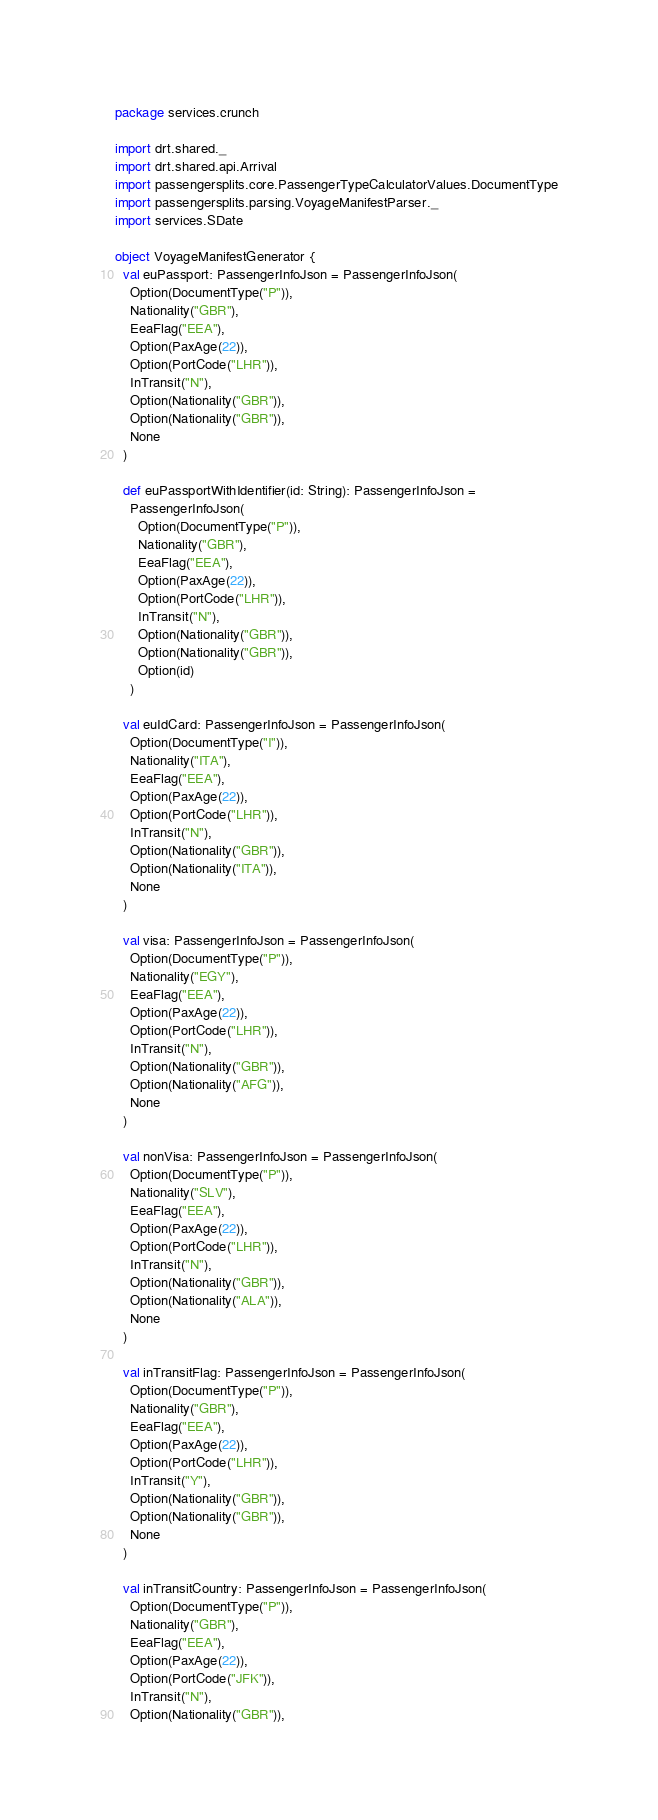<code> <loc_0><loc_0><loc_500><loc_500><_Scala_>package services.crunch

import drt.shared._
import drt.shared.api.Arrival
import passengersplits.core.PassengerTypeCalculatorValues.DocumentType
import passengersplits.parsing.VoyageManifestParser._
import services.SDate

object VoyageManifestGenerator {
  val euPassport: PassengerInfoJson = PassengerInfoJson(
    Option(DocumentType("P")),
    Nationality("GBR"),
    EeaFlag("EEA"),
    Option(PaxAge(22)),
    Option(PortCode("LHR")),
    InTransit("N"),
    Option(Nationality("GBR")),
    Option(Nationality("GBR")),
    None
  )

  def euPassportWithIdentifier(id: String): PassengerInfoJson =
    PassengerInfoJson(
      Option(DocumentType("P")),
      Nationality("GBR"),
      EeaFlag("EEA"),
      Option(PaxAge(22)),
      Option(PortCode("LHR")),
      InTransit("N"),
      Option(Nationality("GBR")),
      Option(Nationality("GBR")),
      Option(id)
    )

  val euIdCard: PassengerInfoJson = PassengerInfoJson(
    Option(DocumentType("I")),
    Nationality("ITA"),
    EeaFlag("EEA"),
    Option(PaxAge(22)),
    Option(PortCode("LHR")),
    InTransit("N"),
    Option(Nationality("GBR")),
    Option(Nationality("ITA")),
    None
  )

  val visa: PassengerInfoJson = PassengerInfoJson(
    Option(DocumentType("P")),
    Nationality("EGY"),
    EeaFlag("EEA"),
    Option(PaxAge(22)),
    Option(PortCode("LHR")),
    InTransit("N"),
    Option(Nationality("GBR")),
    Option(Nationality("AFG")),
    None
  )

  val nonVisa: PassengerInfoJson = PassengerInfoJson(
    Option(DocumentType("P")),
    Nationality("SLV"),
    EeaFlag("EEA"),
    Option(PaxAge(22)),
    Option(PortCode("LHR")),
    InTransit("N"),
    Option(Nationality("GBR")),
    Option(Nationality("ALA")),
    None
  )

  val inTransitFlag: PassengerInfoJson = PassengerInfoJson(
    Option(DocumentType("P")),
    Nationality("GBR"),
    EeaFlag("EEA"),
    Option(PaxAge(22)),
    Option(PortCode("LHR")),
    InTransit("Y"),
    Option(Nationality("GBR")),
    Option(Nationality("GBR")),
    None
  )

  val inTransitCountry: PassengerInfoJson = PassengerInfoJson(
    Option(DocumentType("P")),
    Nationality("GBR"),
    EeaFlag("EEA"),
    Option(PaxAge(22)),
    Option(PortCode("JFK")),
    InTransit("N"),
    Option(Nationality("GBR")),</code> 